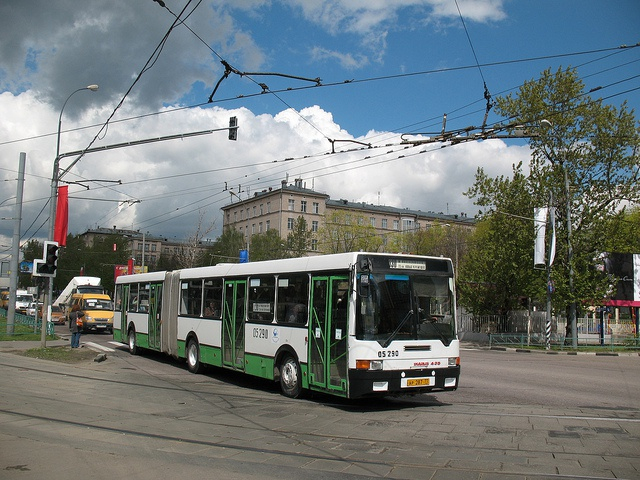Describe the objects in this image and their specific colors. I can see bus in gray, black, lightgray, and darkgray tones, truck in gray, black, orange, and gold tones, truck in gray, white, black, and darkgray tones, traffic light in gray, black, lightgray, and darkgray tones, and people in gray, black, blue, and darkblue tones in this image. 